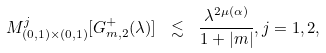Convert formula to latex. <formula><loc_0><loc_0><loc_500><loc_500>M ^ { j } _ { ( 0 , 1 ) \times ( 0 , 1 ) } [ G _ { m , 2 } ^ { + } ( \lambda ) ] \ \lesssim \ \frac { \lambda ^ { 2 \mu ( \alpha ) } } { 1 + | m | } , j = 1 , 2 ,</formula> 